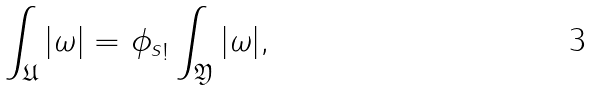<formula> <loc_0><loc_0><loc_500><loc_500>\int _ { \mathfrak U } | \omega | = { \phi _ { s } } _ { ! } \int _ { \mathfrak Y } | \omega | ,</formula> 